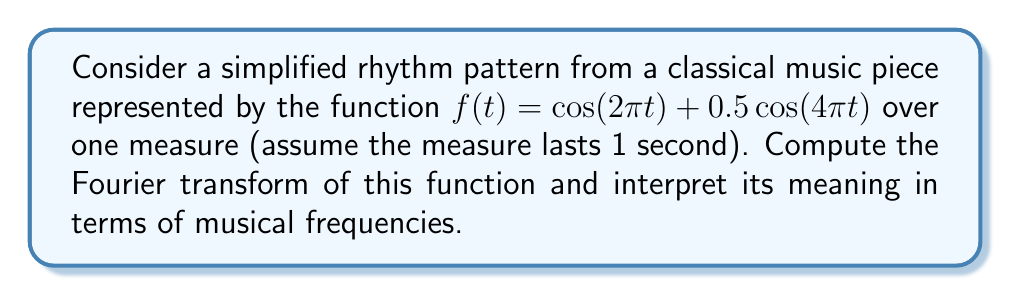Can you solve this math problem? Let's approach this step-by-step:

1) The Fourier transform of a function $f(t)$ is given by:

   $$F(\omega) = \int_{-\infty}^{\infty} f(t) e^{-i\omega t} dt$$

2) Our function is $f(t) = \cos(2\pi t) + 0.5\cos(4\pi t)$

3) We can use the property that the Fourier transform of $\cos(\omega_0 t)$ is:

   $$\mathcal{F}\{\cos(\omega_0 t)\} = \pi[\delta(\omega - \omega_0) + \delta(\omega + \omega_0)]$$

   where $\delta$ is the Dirac delta function.

4) For our function:
   
   $\mathcal{F}\{\cos(2\pi t)\} = \pi[\delta(\omega - 2\pi) + \delta(\omega + 2\pi)]$
   
   $\mathcal{F}\{0.5\cos(4\pi t)\} = 0.5\pi[\delta(\omega - 4\pi) + \delta(\omega + 4\pi)]$

5) Adding these together:

   $$F(\omega) = \pi[\delta(\omega - 2\pi) + \delta(\omega + 2\pi)] + 0.5\pi[\delta(\omega - 4\pi) + \delta(\omega + 4\pi)]$$

6) Interpretation: This result shows two frequency components:
   - A strong component at $\pm 2\pi$ rad/s (or 1 Hz)
   - A weaker component at $\pm 4\pi$ rad/s (or 2 Hz)

   In musical terms, this represents a fundamental frequency (1 Hz) and its first harmonic (2 Hz), with the harmonic being half as strong as the fundamental.
Answer: $F(\omega) = \pi[\delta(\omega - 2\pi) + \delta(\omega + 2\pi)] + 0.5\pi[\delta(\omega - 4\pi) + \delta(\omega + 4\pi)]$ 